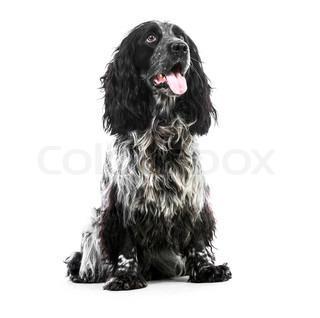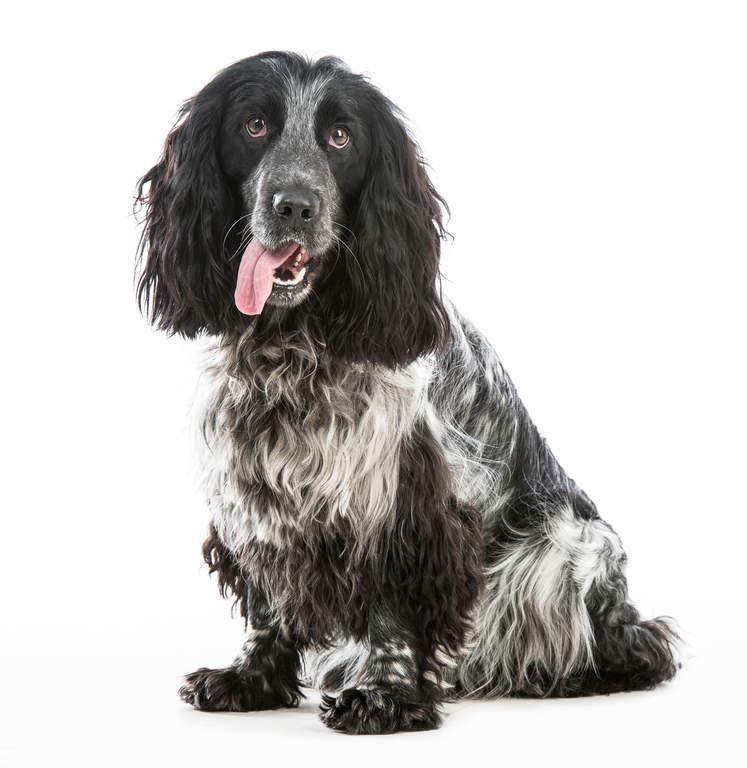The first image is the image on the left, the second image is the image on the right. Analyze the images presented: Is the assertion "At least one of the dogs has its tongue handing out." valid? Answer yes or no. Yes. The first image is the image on the left, the second image is the image on the right. For the images shown, is this caption "An image shows exactly one dog colored dark chocolate brown." true? Answer yes or no. No. 